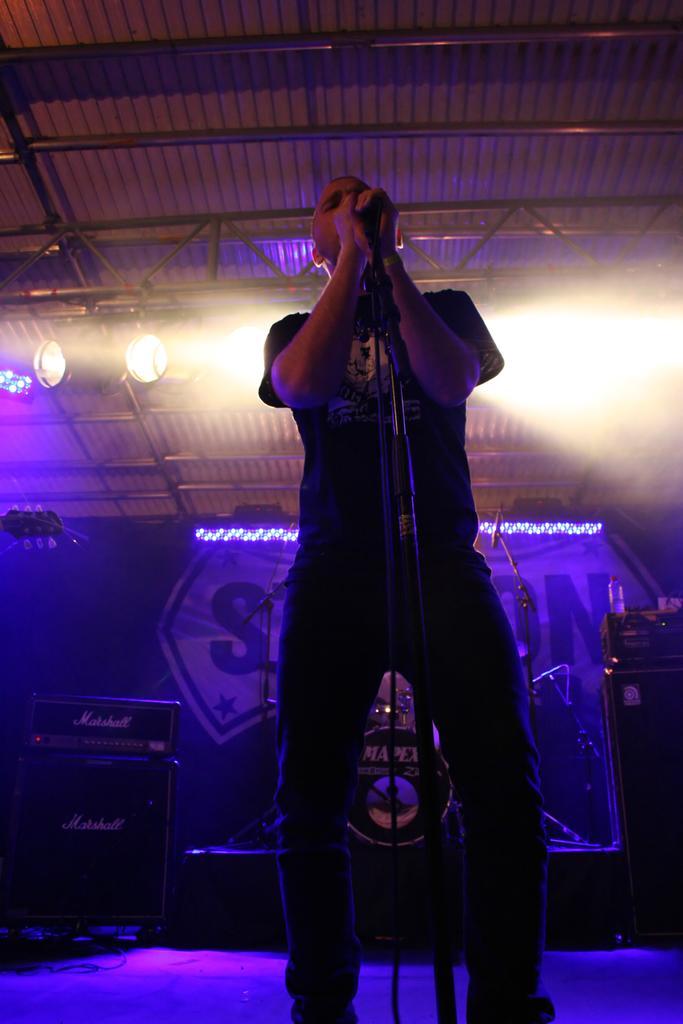Can you describe this image briefly? In this image there is a person standing and holding a mike, and there are speakers, focus lights, lighting truss and a banner. 